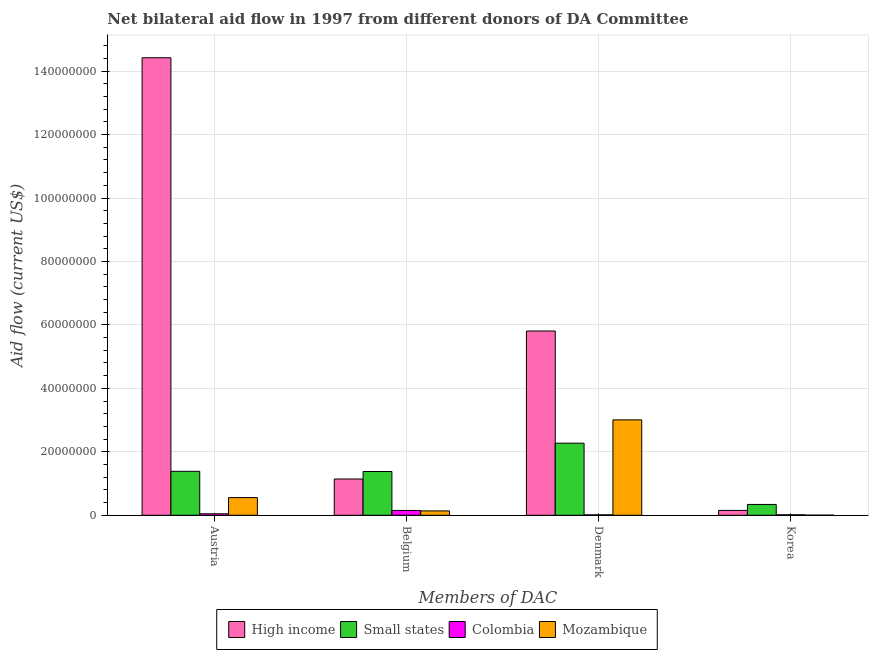How many groups of bars are there?
Provide a short and direct response. 4. Are the number of bars on each tick of the X-axis equal?
Keep it short and to the point. Yes. How many bars are there on the 4th tick from the left?
Your answer should be compact. 4. How many bars are there on the 1st tick from the right?
Provide a succinct answer. 4. What is the label of the 4th group of bars from the left?
Provide a short and direct response. Korea. What is the amount of aid given by korea in Mozambique?
Offer a very short reply. 3.00e+04. Across all countries, what is the maximum amount of aid given by belgium?
Keep it short and to the point. 1.38e+07. Across all countries, what is the minimum amount of aid given by korea?
Provide a short and direct response. 3.00e+04. In which country was the amount of aid given by belgium maximum?
Your answer should be compact. Small states. In which country was the amount of aid given by belgium minimum?
Your answer should be very brief. Mozambique. What is the total amount of aid given by belgium in the graph?
Give a very brief answer. 2.81e+07. What is the difference between the amount of aid given by korea in High income and that in Colombia?
Make the answer very short. 1.38e+06. What is the difference between the amount of aid given by denmark in Small states and the amount of aid given by korea in Colombia?
Give a very brief answer. 2.26e+07. What is the average amount of aid given by austria per country?
Your response must be concise. 4.10e+07. What is the difference between the amount of aid given by denmark and amount of aid given by austria in Small states?
Give a very brief answer. 8.87e+06. What is the ratio of the amount of aid given by korea in Small states to that in High income?
Give a very brief answer. 2.23. What is the difference between the highest and the second highest amount of aid given by korea?
Keep it short and to the point. 1.88e+06. What is the difference between the highest and the lowest amount of aid given by austria?
Your answer should be compact. 1.44e+08. Is it the case that in every country, the sum of the amount of aid given by belgium and amount of aid given by denmark is greater than the sum of amount of aid given by austria and amount of aid given by korea?
Your response must be concise. Yes. What does the 4th bar from the left in Korea represents?
Your response must be concise. Mozambique. What does the 3rd bar from the right in Denmark represents?
Offer a very short reply. Small states. Are all the bars in the graph horizontal?
Provide a succinct answer. No. What is the difference between two consecutive major ticks on the Y-axis?
Give a very brief answer. 2.00e+07. Does the graph contain any zero values?
Offer a very short reply. No. Where does the legend appear in the graph?
Provide a short and direct response. Bottom center. How many legend labels are there?
Your answer should be compact. 4. How are the legend labels stacked?
Provide a short and direct response. Horizontal. What is the title of the graph?
Your response must be concise. Net bilateral aid flow in 1997 from different donors of DA Committee. What is the label or title of the X-axis?
Your answer should be very brief. Members of DAC. What is the Aid flow (current US$) in High income in Austria?
Offer a very short reply. 1.44e+08. What is the Aid flow (current US$) in Small states in Austria?
Your response must be concise. 1.38e+07. What is the Aid flow (current US$) of Mozambique in Austria?
Make the answer very short. 5.56e+06. What is the Aid flow (current US$) of High income in Belgium?
Your answer should be very brief. 1.14e+07. What is the Aid flow (current US$) in Small states in Belgium?
Offer a terse response. 1.38e+07. What is the Aid flow (current US$) of Colombia in Belgium?
Your answer should be compact. 1.52e+06. What is the Aid flow (current US$) of Mozambique in Belgium?
Provide a succinct answer. 1.37e+06. What is the Aid flow (current US$) in High income in Denmark?
Ensure brevity in your answer.  5.81e+07. What is the Aid flow (current US$) of Small states in Denmark?
Provide a short and direct response. 2.27e+07. What is the Aid flow (current US$) in Colombia in Denmark?
Your answer should be compact. 1.30e+05. What is the Aid flow (current US$) in Mozambique in Denmark?
Offer a terse response. 3.01e+07. What is the Aid flow (current US$) in High income in Korea?
Your response must be concise. 1.53e+06. What is the Aid flow (current US$) of Small states in Korea?
Ensure brevity in your answer.  3.41e+06. What is the Aid flow (current US$) of Mozambique in Korea?
Your answer should be very brief. 3.00e+04. Across all Members of DAC, what is the maximum Aid flow (current US$) in High income?
Your answer should be very brief. 1.44e+08. Across all Members of DAC, what is the maximum Aid flow (current US$) of Small states?
Provide a succinct answer. 2.27e+07. Across all Members of DAC, what is the maximum Aid flow (current US$) of Colombia?
Provide a succinct answer. 1.52e+06. Across all Members of DAC, what is the maximum Aid flow (current US$) of Mozambique?
Make the answer very short. 3.01e+07. Across all Members of DAC, what is the minimum Aid flow (current US$) of High income?
Provide a short and direct response. 1.53e+06. Across all Members of DAC, what is the minimum Aid flow (current US$) of Small states?
Offer a very short reply. 3.41e+06. What is the total Aid flow (current US$) in High income in the graph?
Your answer should be compact. 2.15e+08. What is the total Aid flow (current US$) of Small states in the graph?
Give a very brief answer. 5.38e+07. What is the total Aid flow (current US$) of Colombia in the graph?
Keep it short and to the point. 2.26e+06. What is the total Aid flow (current US$) of Mozambique in the graph?
Give a very brief answer. 3.70e+07. What is the difference between the Aid flow (current US$) of High income in Austria and that in Belgium?
Offer a terse response. 1.33e+08. What is the difference between the Aid flow (current US$) of Colombia in Austria and that in Belgium?
Give a very brief answer. -1.06e+06. What is the difference between the Aid flow (current US$) of Mozambique in Austria and that in Belgium?
Your response must be concise. 4.19e+06. What is the difference between the Aid flow (current US$) of High income in Austria and that in Denmark?
Provide a succinct answer. 8.61e+07. What is the difference between the Aid flow (current US$) of Small states in Austria and that in Denmark?
Offer a terse response. -8.87e+06. What is the difference between the Aid flow (current US$) in Colombia in Austria and that in Denmark?
Your response must be concise. 3.30e+05. What is the difference between the Aid flow (current US$) of Mozambique in Austria and that in Denmark?
Give a very brief answer. -2.45e+07. What is the difference between the Aid flow (current US$) in High income in Austria and that in Korea?
Your response must be concise. 1.43e+08. What is the difference between the Aid flow (current US$) in Small states in Austria and that in Korea?
Offer a terse response. 1.04e+07. What is the difference between the Aid flow (current US$) of Colombia in Austria and that in Korea?
Keep it short and to the point. 3.10e+05. What is the difference between the Aid flow (current US$) of Mozambique in Austria and that in Korea?
Your response must be concise. 5.53e+06. What is the difference between the Aid flow (current US$) in High income in Belgium and that in Denmark?
Give a very brief answer. -4.66e+07. What is the difference between the Aid flow (current US$) in Small states in Belgium and that in Denmark?
Offer a very short reply. -8.93e+06. What is the difference between the Aid flow (current US$) of Colombia in Belgium and that in Denmark?
Keep it short and to the point. 1.39e+06. What is the difference between the Aid flow (current US$) in Mozambique in Belgium and that in Denmark?
Your answer should be very brief. -2.87e+07. What is the difference between the Aid flow (current US$) of High income in Belgium and that in Korea?
Your answer should be very brief. 9.90e+06. What is the difference between the Aid flow (current US$) of Small states in Belgium and that in Korea?
Your answer should be compact. 1.04e+07. What is the difference between the Aid flow (current US$) in Colombia in Belgium and that in Korea?
Ensure brevity in your answer.  1.37e+06. What is the difference between the Aid flow (current US$) of Mozambique in Belgium and that in Korea?
Provide a succinct answer. 1.34e+06. What is the difference between the Aid flow (current US$) of High income in Denmark and that in Korea?
Your response must be concise. 5.66e+07. What is the difference between the Aid flow (current US$) of Small states in Denmark and that in Korea?
Provide a succinct answer. 1.93e+07. What is the difference between the Aid flow (current US$) of Colombia in Denmark and that in Korea?
Make the answer very short. -2.00e+04. What is the difference between the Aid flow (current US$) of Mozambique in Denmark and that in Korea?
Offer a very short reply. 3.00e+07. What is the difference between the Aid flow (current US$) in High income in Austria and the Aid flow (current US$) in Small states in Belgium?
Offer a very short reply. 1.30e+08. What is the difference between the Aid flow (current US$) in High income in Austria and the Aid flow (current US$) in Colombia in Belgium?
Make the answer very short. 1.43e+08. What is the difference between the Aid flow (current US$) in High income in Austria and the Aid flow (current US$) in Mozambique in Belgium?
Keep it short and to the point. 1.43e+08. What is the difference between the Aid flow (current US$) of Small states in Austria and the Aid flow (current US$) of Colombia in Belgium?
Give a very brief answer. 1.23e+07. What is the difference between the Aid flow (current US$) of Small states in Austria and the Aid flow (current US$) of Mozambique in Belgium?
Ensure brevity in your answer.  1.25e+07. What is the difference between the Aid flow (current US$) in Colombia in Austria and the Aid flow (current US$) in Mozambique in Belgium?
Offer a very short reply. -9.10e+05. What is the difference between the Aid flow (current US$) in High income in Austria and the Aid flow (current US$) in Small states in Denmark?
Ensure brevity in your answer.  1.22e+08. What is the difference between the Aid flow (current US$) of High income in Austria and the Aid flow (current US$) of Colombia in Denmark?
Provide a short and direct response. 1.44e+08. What is the difference between the Aid flow (current US$) in High income in Austria and the Aid flow (current US$) in Mozambique in Denmark?
Provide a short and direct response. 1.14e+08. What is the difference between the Aid flow (current US$) in Small states in Austria and the Aid flow (current US$) in Colombia in Denmark?
Ensure brevity in your answer.  1.37e+07. What is the difference between the Aid flow (current US$) of Small states in Austria and the Aid flow (current US$) of Mozambique in Denmark?
Your answer should be compact. -1.62e+07. What is the difference between the Aid flow (current US$) of Colombia in Austria and the Aid flow (current US$) of Mozambique in Denmark?
Make the answer very short. -2.96e+07. What is the difference between the Aid flow (current US$) of High income in Austria and the Aid flow (current US$) of Small states in Korea?
Give a very brief answer. 1.41e+08. What is the difference between the Aid flow (current US$) in High income in Austria and the Aid flow (current US$) in Colombia in Korea?
Your answer should be compact. 1.44e+08. What is the difference between the Aid flow (current US$) in High income in Austria and the Aid flow (current US$) in Mozambique in Korea?
Ensure brevity in your answer.  1.44e+08. What is the difference between the Aid flow (current US$) in Small states in Austria and the Aid flow (current US$) in Colombia in Korea?
Keep it short and to the point. 1.37e+07. What is the difference between the Aid flow (current US$) in Small states in Austria and the Aid flow (current US$) in Mozambique in Korea?
Make the answer very short. 1.38e+07. What is the difference between the Aid flow (current US$) of Colombia in Austria and the Aid flow (current US$) of Mozambique in Korea?
Offer a very short reply. 4.30e+05. What is the difference between the Aid flow (current US$) of High income in Belgium and the Aid flow (current US$) of Small states in Denmark?
Provide a succinct answer. -1.13e+07. What is the difference between the Aid flow (current US$) in High income in Belgium and the Aid flow (current US$) in Colombia in Denmark?
Provide a short and direct response. 1.13e+07. What is the difference between the Aid flow (current US$) in High income in Belgium and the Aid flow (current US$) in Mozambique in Denmark?
Your answer should be very brief. -1.86e+07. What is the difference between the Aid flow (current US$) of Small states in Belgium and the Aid flow (current US$) of Colombia in Denmark?
Provide a short and direct response. 1.37e+07. What is the difference between the Aid flow (current US$) of Small states in Belgium and the Aid flow (current US$) of Mozambique in Denmark?
Offer a terse response. -1.63e+07. What is the difference between the Aid flow (current US$) of Colombia in Belgium and the Aid flow (current US$) of Mozambique in Denmark?
Make the answer very short. -2.86e+07. What is the difference between the Aid flow (current US$) of High income in Belgium and the Aid flow (current US$) of Small states in Korea?
Keep it short and to the point. 8.02e+06. What is the difference between the Aid flow (current US$) of High income in Belgium and the Aid flow (current US$) of Colombia in Korea?
Give a very brief answer. 1.13e+07. What is the difference between the Aid flow (current US$) of High income in Belgium and the Aid flow (current US$) of Mozambique in Korea?
Ensure brevity in your answer.  1.14e+07. What is the difference between the Aid flow (current US$) of Small states in Belgium and the Aid flow (current US$) of Colombia in Korea?
Offer a terse response. 1.36e+07. What is the difference between the Aid flow (current US$) of Small states in Belgium and the Aid flow (current US$) of Mozambique in Korea?
Keep it short and to the point. 1.38e+07. What is the difference between the Aid flow (current US$) in Colombia in Belgium and the Aid flow (current US$) in Mozambique in Korea?
Provide a short and direct response. 1.49e+06. What is the difference between the Aid flow (current US$) of High income in Denmark and the Aid flow (current US$) of Small states in Korea?
Provide a short and direct response. 5.47e+07. What is the difference between the Aid flow (current US$) in High income in Denmark and the Aid flow (current US$) in Colombia in Korea?
Offer a terse response. 5.79e+07. What is the difference between the Aid flow (current US$) in High income in Denmark and the Aid flow (current US$) in Mozambique in Korea?
Provide a short and direct response. 5.80e+07. What is the difference between the Aid flow (current US$) of Small states in Denmark and the Aid flow (current US$) of Colombia in Korea?
Ensure brevity in your answer.  2.26e+07. What is the difference between the Aid flow (current US$) of Small states in Denmark and the Aid flow (current US$) of Mozambique in Korea?
Make the answer very short. 2.27e+07. What is the difference between the Aid flow (current US$) of Colombia in Denmark and the Aid flow (current US$) of Mozambique in Korea?
Your answer should be very brief. 1.00e+05. What is the average Aid flow (current US$) of High income per Members of DAC?
Offer a terse response. 5.38e+07. What is the average Aid flow (current US$) of Small states per Members of DAC?
Provide a succinct answer. 1.34e+07. What is the average Aid flow (current US$) in Colombia per Members of DAC?
Give a very brief answer. 5.65e+05. What is the average Aid flow (current US$) in Mozambique per Members of DAC?
Provide a short and direct response. 9.26e+06. What is the difference between the Aid flow (current US$) of High income and Aid flow (current US$) of Small states in Austria?
Ensure brevity in your answer.  1.30e+08. What is the difference between the Aid flow (current US$) of High income and Aid flow (current US$) of Colombia in Austria?
Your answer should be compact. 1.44e+08. What is the difference between the Aid flow (current US$) of High income and Aid flow (current US$) of Mozambique in Austria?
Provide a short and direct response. 1.39e+08. What is the difference between the Aid flow (current US$) of Small states and Aid flow (current US$) of Colombia in Austria?
Offer a very short reply. 1.34e+07. What is the difference between the Aid flow (current US$) of Small states and Aid flow (current US$) of Mozambique in Austria?
Provide a succinct answer. 8.29e+06. What is the difference between the Aid flow (current US$) in Colombia and Aid flow (current US$) in Mozambique in Austria?
Make the answer very short. -5.10e+06. What is the difference between the Aid flow (current US$) in High income and Aid flow (current US$) in Small states in Belgium?
Your answer should be compact. -2.36e+06. What is the difference between the Aid flow (current US$) in High income and Aid flow (current US$) in Colombia in Belgium?
Provide a succinct answer. 9.91e+06. What is the difference between the Aid flow (current US$) in High income and Aid flow (current US$) in Mozambique in Belgium?
Keep it short and to the point. 1.01e+07. What is the difference between the Aid flow (current US$) of Small states and Aid flow (current US$) of Colombia in Belgium?
Keep it short and to the point. 1.23e+07. What is the difference between the Aid flow (current US$) in Small states and Aid flow (current US$) in Mozambique in Belgium?
Offer a terse response. 1.24e+07. What is the difference between the Aid flow (current US$) in Colombia and Aid flow (current US$) in Mozambique in Belgium?
Make the answer very short. 1.50e+05. What is the difference between the Aid flow (current US$) in High income and Aid flow (current US$) in Small states in Denmark?
Give a very brief answer. 3.54e+07. What is the difference between the Aid flow (current US$) in High income and Aid flow (current US$) in Colombia in Denmark?
Give a very brief answer. 5.80e+07. What is the difference between the Aid flow (current US$) in High income and Aid flow (current US$) in Mozambique in Denmark?
Offer a very short reply. 2.80e+07. What is the difference between the Aid flow (current US$) in Small states and Aid flow (current US$) in Colombia in Denmark?
Offer a very short reply. 2.26e+07. What is the difference between the Aid flow (current US$) of Small states and Aid flow (current US$) of Mozambique in Denmark?
Provide a succinct answer. -7.35e+06. What is the difference between the Aid flow (current US$) in Colombia and Aid flow (current US$) in Mozambique in Denmark?
Provide a short and direct response. -2.99e+07. What is the difference between the Aid flow (current US$) in High income and Aid flow (current US$) in Small states in Korea?
Your answer should be compact. -1.88e+06. What is the difference between the Aid flow (current US$) of High income and Aid flow (current US$) of Colombia in Korea?
Provide a short and direct response. 1.38e+06. What is the difference between the Aid flow (current US$) of High income and Aid flow (current US$) of Mozambique in Korea?
Ensure brevity in your answer.  1.50e+06. What is the difference between the Aid flow (current US$) in Small states and Aid flow (current US$) in Colombia in Korea?
Offer a terse response. 3.26e+06. What is the difference between the Aid flow (current US$) in Small states and Aid flow (current US$) in Mozambique in Korea?
Your answer should be very brief. 3.38e+06. What is the ratio of the Aid flow (current US$) of High income in Austria to that in Belgium?
Offer a very short reply. 12.62. What is the ratio of the Aid flow (current US$) of Colombia in Austria to that in Belgium?
Give a very brief answer. 0.3. What is the ratio of the Aid flow (current US$) of Mozambique in Austria to that in Belgium?
Ensure brevity in your answer.  4.06. What is the ratio of the Aid flow (current US$) of High income in Austria to that in Denmark?
Provide a succinct answer. 2.48. What is the ratio of the Aid flow (current US$) in Small states in Austria to that in Denmark?
Provide a short and direct response. 0.61. What is the ratio of the Aid flow (current US$) of Colombia in Austria to that in Denmark?
Offer a terse response. 3.54. What is the ratio of the Aid flow (current US$) of Mozambique in Austria to that in Denmark?
Provide a succinct answer. 0.18. What is the ratio of the Aid flow (current US$) of High income in Austria to that in Korea?
Your answer should be very brief. 94.26. What is the ratio of the Aid flow (current US$) of Small states in Austria to that in Korea?
Your response must be concise. 4.06. What is the ratio of the Aid flow (current US$) in Colombia in Austria to that in Korea?
Offer a very short reply. 3.07. What is the ratio of the Aid flow (current US$) of Mozambique in Austria to that in Korea?
Offer a terse response. 185.33. What is the ratio of the Aid flow (current US$) in High income in Belgium to that in Denmark?
Keep it short and to the point. 0.2. What is the ratio of the Aid flow (current US$) of Small states in Belgium to that in Denmark?
Your answer should be very brief. 0.61. What is the ratio of the Aid flow (current US$) of Colombia in Belgium to that in Denmark?
Offer a terse response. 11.69. What is the ratio of the Aid flow (current US$) of Mozambique in Belgium to that in Denmark?
Ensure brevity in your answer.  0.05. What is the ratio of the Aid flow (current US$) of High income in Belgium to that in Korea?
Offer a very short reply. 7.47. What is the ratio of the Aid flow (current US$) in Small states in Belgium to that in Korea?
Your response must be concise. 4.04. What is the ratio of the Aid flow (current US$) in Colombia in Belgium to that in Korea?
Your response must be concise. 10.13. What is the ratio of the Aid flow (current US$) of Mozambique in Belgium to that in Korea?
Your response must be concise. 45.67. What is the ratio of the Aid flow (current US$) in High income in Denmark to that in Korea?
Give a very brief answer. 37.96. What is the ratio of the Aid flow (current US$) of Small states in Denmark to that in Korea?
Provide a short and direct response. 6.66. What is the ratio of the Aid flow (current US$) in Colombia in Denmark to that in Korea?
Offer a terse response. 0.87. What is the ratio of the Aid flow (current US$) of Mozambique in Denmark to that in Korea?
Your answer should be very brief. 1002.33. What is the difference between the highest and the second highest Aid flow (current US$) of High income?
Provide a succinct answer. 8.61e+07. What is the difference between the highest and the second highest Aid flow (current US$) of Small states?
Ensure brevity in your answer.  8.87e+06. What is the difference between the highest and the second highest Aid flow (current US$) in Colombia?
Give a very brief answer. 1.06e+06. What is the difference between the highest and the second highest Aid flow (current US$) of Mozambique?
Give a very brief answer. 2.45e+07. What is the difference between the highest and the lowest Aid flow (current US$) of High income?
Your response must be concise. 1.43e+08. What is the difference between the highest and the lowest Aid flow (current US$) of Small states?
Your answer should be very brief. 1.93e+07. What is the difference between the highest and the lowest Aid flow (current US$) in Colombia?
Ensure brevity in your answer.  1.39e+06. What is the difference between the highest and the lowest Aid flow (current US$) in Mozambique?
Provide a succinct answer. 3.00e+07. 